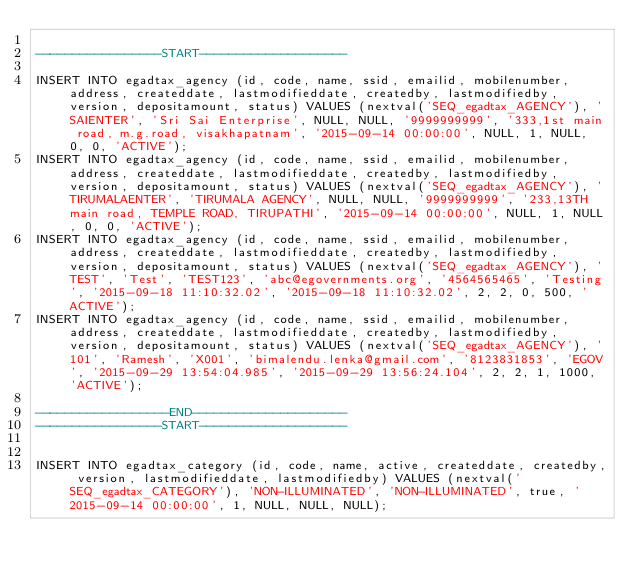<code> <loc_0><loc_0><loc_500><loc_500><_SQL_>
-----------------START--------------------

INSERT INTO egadtax_agency (id, code, name, ssid, emailid, mobilenumber, address, createddate, lastmodifieddate, createdby, lastmodifiedby, version, depositamount, status) VALUES (nextval('SEQ_egadtax_AGENCY'), 'SAIENTER', 'Sri Sai Enterprise', NULL, NULL, '9999999999', '333,1st main road, m.g.road, visakhapatnam', '2015-09-14 00:00:00', NULL, 1, NULL, 0, 0, 'ACTIVE');
INSERT INTO egadtax_agency (id, code, name, ssid, emailid, mobilenumber, address, createddate, lastmodifieddate, createdby, lastmodifiedby, version, depositamount, status) VALUES (nextval('SEQ_egadtax_AGENCY'), 'TIRUMALAENTER', 'TIRUMALA AGENCY', NULL, NULL, '9999999999', '233,13TH main road, TEMPLE ROAD, TIRUPATHI', '2015-09-14 00:00:00', NULL, 1, NULL, 0, 0, 'ACTIVE');
INSERT INTO egadtax_agency (id, code, name, ssid, emailid, mobilenumber, address, createddate, lastmodifieddate, createdby, lastmodifiedby, version, depositamount, status) VALUES (nextval('SEQ_egadtax_AGENCY'), 'TEST', 'Test', 'TEST123', 'abc@egovernments.org', '4564565465', 'Testing', '2015-09-18 11:10:32.02', '2015-09-18 11:10:32.02', 2, 2, 0, 500, 'ACTIVE');
INSERT INTO egadtax_agency (id, code, name, ssid, emailid, mobilenumber, address, createddate, lastmodifieddate, createdby, lastmodifiedby, version, depositamount, status) VALUES (nextval('SEQ_egadtax_AGENCY'), '101', 'Ramesh', 'X001', 'bimalendu.lenka@gmail.com', '8123831853', 'EGOV', '2015-09-29 13:54:04.985', '2015-09-29 13:56:24.104', 2, 2, 1, 1000, 'ACTIVE');

------------------END---------------------
-----------------START--------------------


INSERT INTO egadtax_category (id, code, name, active, createddate, createdby, version, lastmodifieddate, lastmodifiedby) VALUES (nextval('SEQ_egadtax_CATEGORY'), 'NON-ILLUMINATED', 'NON-ILLUMINATED', true, '2015-09-14 00:00:00', 1, NULL, NULL, NULL);</code> 